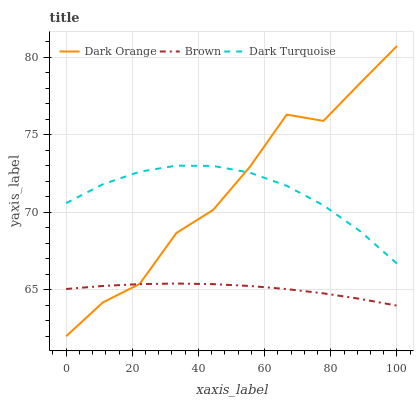Does Brown have the minimum area under the curve?
Answer yes or no. Yes. Does Dark Orange have the maximum area under the curve?
Answer yes or no. Yes. Does Dark Turquoise have the minimum area under the curve?
Answer yes or no. No. Does Dark Turquoise have the maximum area under the curve?
Answer yes or no. No. Is Brown the smoothest?
Answer yes or no. Yes. Is Dark Orange the roughest?
Answer yes or no. Yes. Is Dark Turquoise the smoothest?
Answer yes or no. No. Is Dark Turquoise the roughest?
Answer yes or no. No. Does Dark Orange have the lowest value?
Answer yes or no. Yes. Does Brown have the lowest value?
Answer yes or no. No. Does Dark Orange have the highest value?
Answer yes or no. Yes. Does Dark Turquoise have the highest value?
Answer yes or no. No. Is Brown less than Dark Turquoise?
Answer yes or no. Yes. Is Dark Turquoise greater than Brown?
Answer yes or no. Yes. Does Dark Turquoise intersect Dark Orange?
Answer yes or no. Yes. Is Dark Turquoise less than Dark Orange?
Answer yes or no. No. Is Dark Turquoise greater than Dark Orange?
Answer yes or no. No. Does Brown intersect Dark Turquoise?
Answer yes or no. No. 